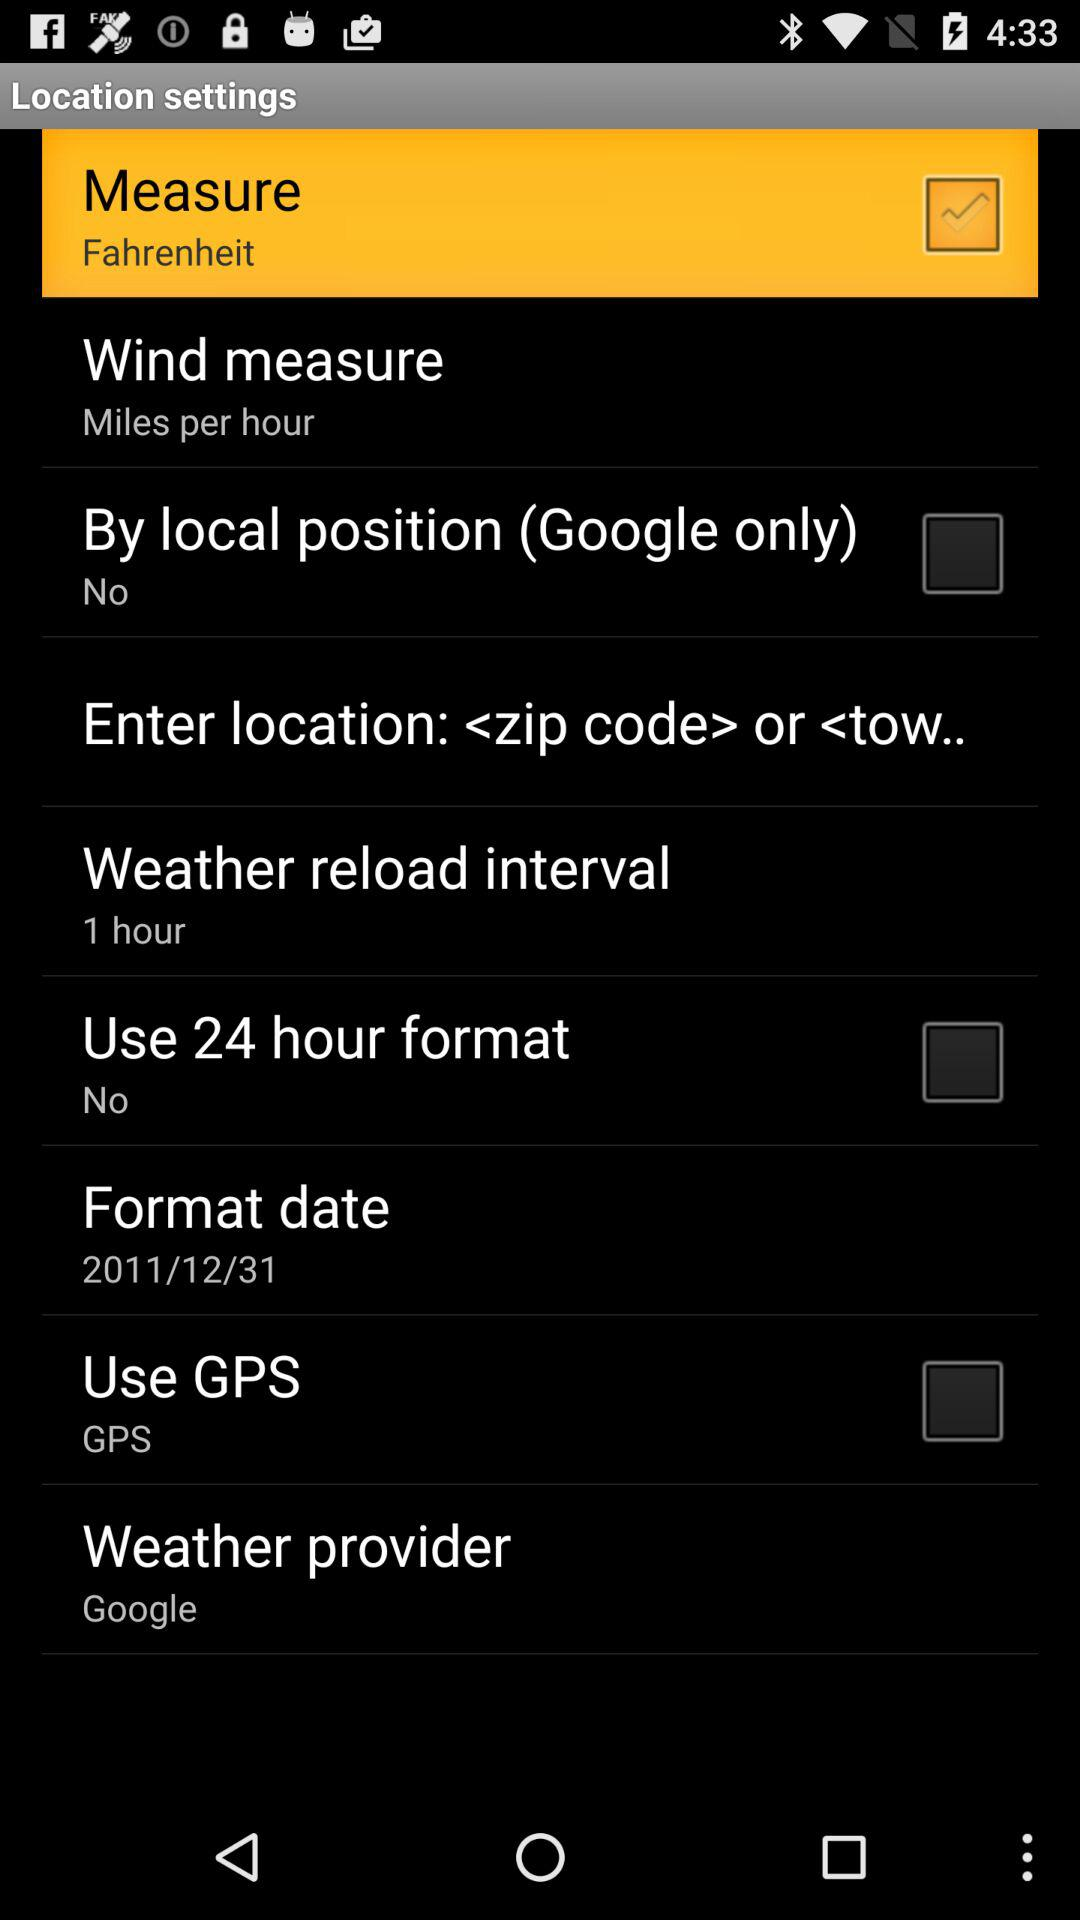Who is the weather provider? The weather provider is Google. 